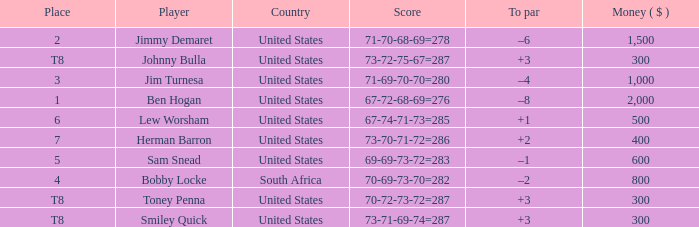What is the Score of the game of the Player in Place 4? 70-69-73-70=282. 